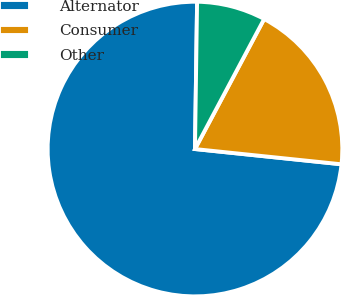<chart> <loc_0><loc_0><loc_500><loc_500><pie_chart><fcel>Alternator<fcel>Consumer<fcel>Other<nl><fcel>73.58%<fcel>18.87%<fcel>7.55%<nl></chart> 